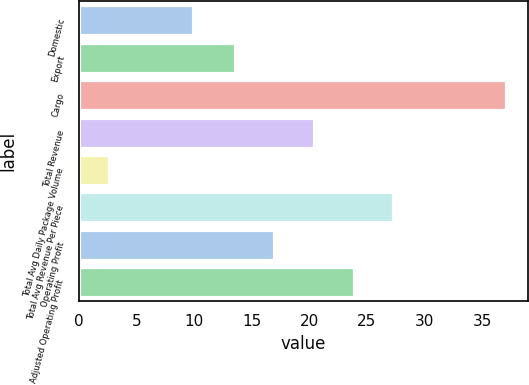Convert chart to OTSL. <chart><loc_0><loc_0><loc_500><loc_500><bar_chart><fcel>Domestic<fcel>Export<fcel>Cargo<fcel>Total Revenue<fcel>Total Avg Daily Package Volume<fcel>Total Avg Revenue Per Piece<fcel>Operating Profit<fcel>Adjusted Operating Profit<nl><fcel>9.9<fcel>13.5<fcel>37.1<fcel>20.4<fcel>2.6<fcel>27.3<fcel>16.95<fcel>23.85<nl></chart> 